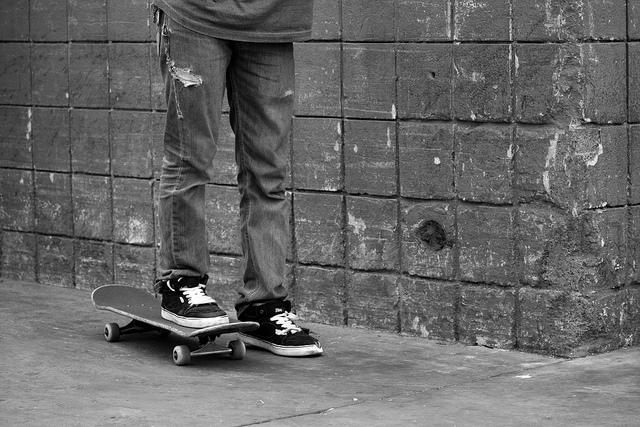What is the only color in the photo?
Be succinct. Gray. What color are the young man's shoelaces?
Answer briefly. White. Is this a young or older person on the skateboard?
Short answer required. Young. Are the persons jeans ripped?
Short answer required. Yes. 